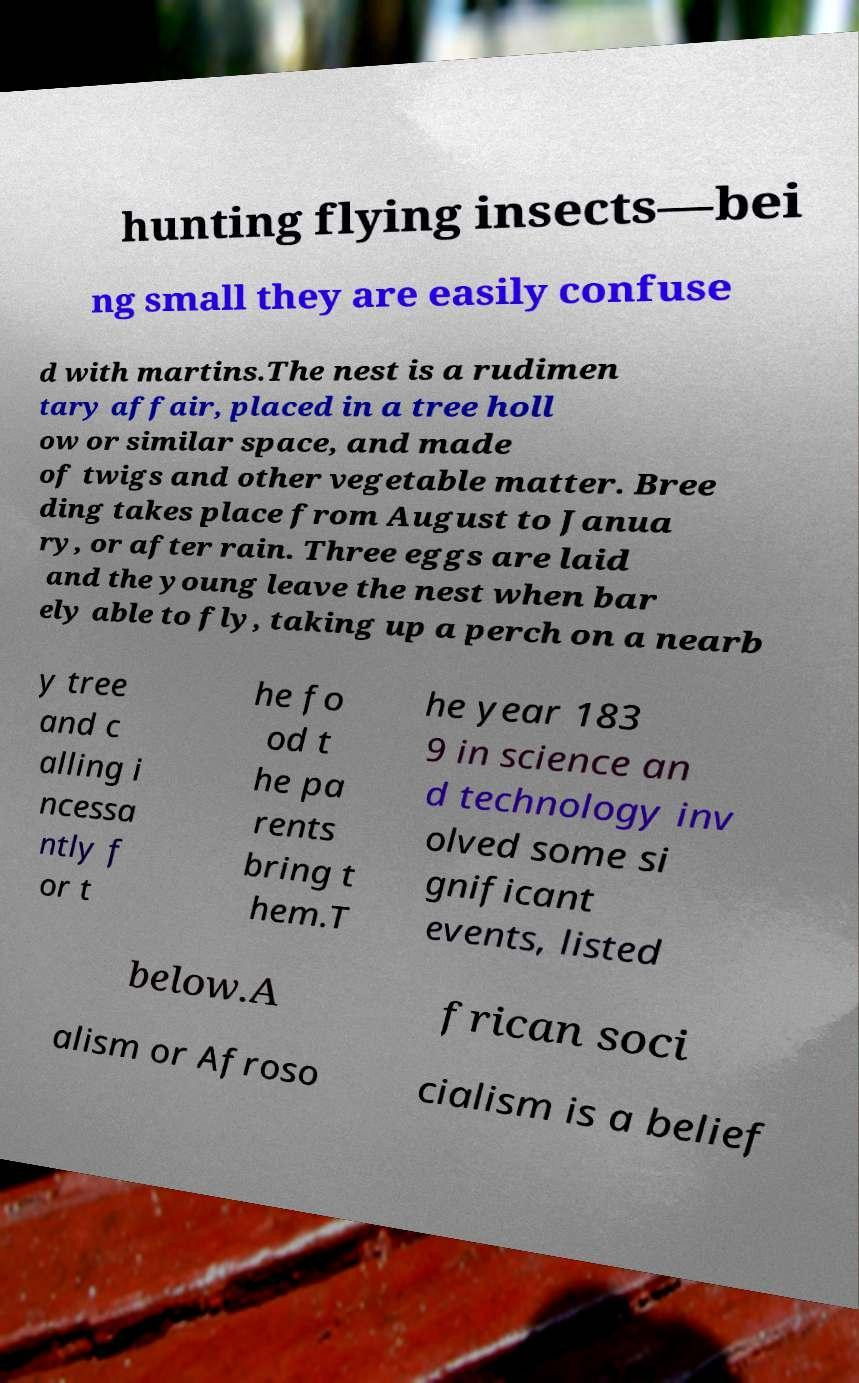What messages or text are displayed in this image? I need them in a readable, typed format. hunting flying insects—bei ng small they are easily confuse d with martins.The nest is a rudimen tary affair, placed in a tree holl ow or similar space, and made of twigs and other vegetable matter. Bree ding takes place from August to Janua ry, or after rain. Three eggs are laid and the young leave the nest when bar ely able to fly, taking up a perch on a nearb y tree and c alling i ncessa ntly f or t he fo od t he pa rents bring t hem.T he year 183 9 in science an d technology inv olved some si gnificant events, listed below.A frican soci alism or Afroso cialism is a belief 